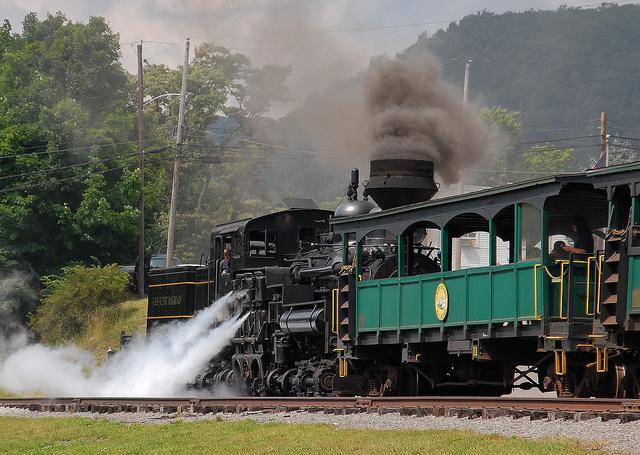How many toothbrushes are on the counter?
Give a very brief answer. 0. 